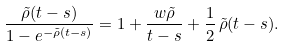Convert formula to latex. <formula><loc_0><loc_0><loc_500><loc_500>\frac { \tilde { \rho } ( t - s ) } { 1 - e ^ { - \tilde { \rho } ( t - s ) } } = 1 + \frac { w \tilde { \rho } } { t - s } + \frac { 1 } { 2 } \, \tilde { \rho } ( t - s ) .</formula> 